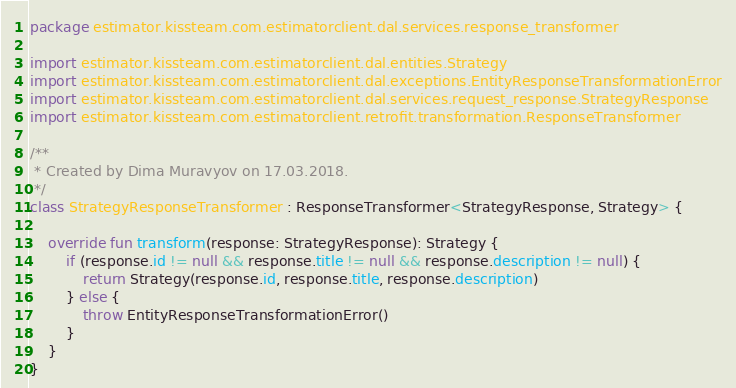<code> <loc_0><loc_0><loc_500><loc_500><_Kotlin_>package estimator.kissteam.com.estimatorclient.dal.services.response_transformer

import estimator.kissteam.com.estimatorclient.dal.entities.Strategy
import estimator.kissteam.com.estimatorclient.dal.exceptions.EntityResponseTransformationError
import estimator.kissteam.com.estimatorclient.dal.services.request_response.StrategyResponse
import estimator.kissteam.com.estimatorclient.retrofit.transformation.ResponseTransformer

/**
 * Created by Dima Muravyov on 17.03.2018.
 */
class StrategyResponseTransformer : ResponseTransformer<StrategyResponse, Strategy> {

	override fun transform(response: StrategyResponse): Strategy {
		if (response.id != null && response.title != null && response.description != null) {
			return Strategy(response.id, response.title, response.description)
		} else {
			throw EntityResponseTransformationError()
		}
	}
}</code> 